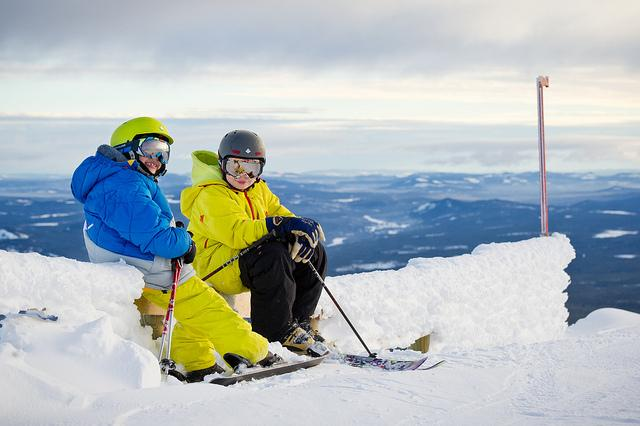What are they doing? Please explain your reasoning. resting. Their seated position shows that they are resting before the next ski run. 